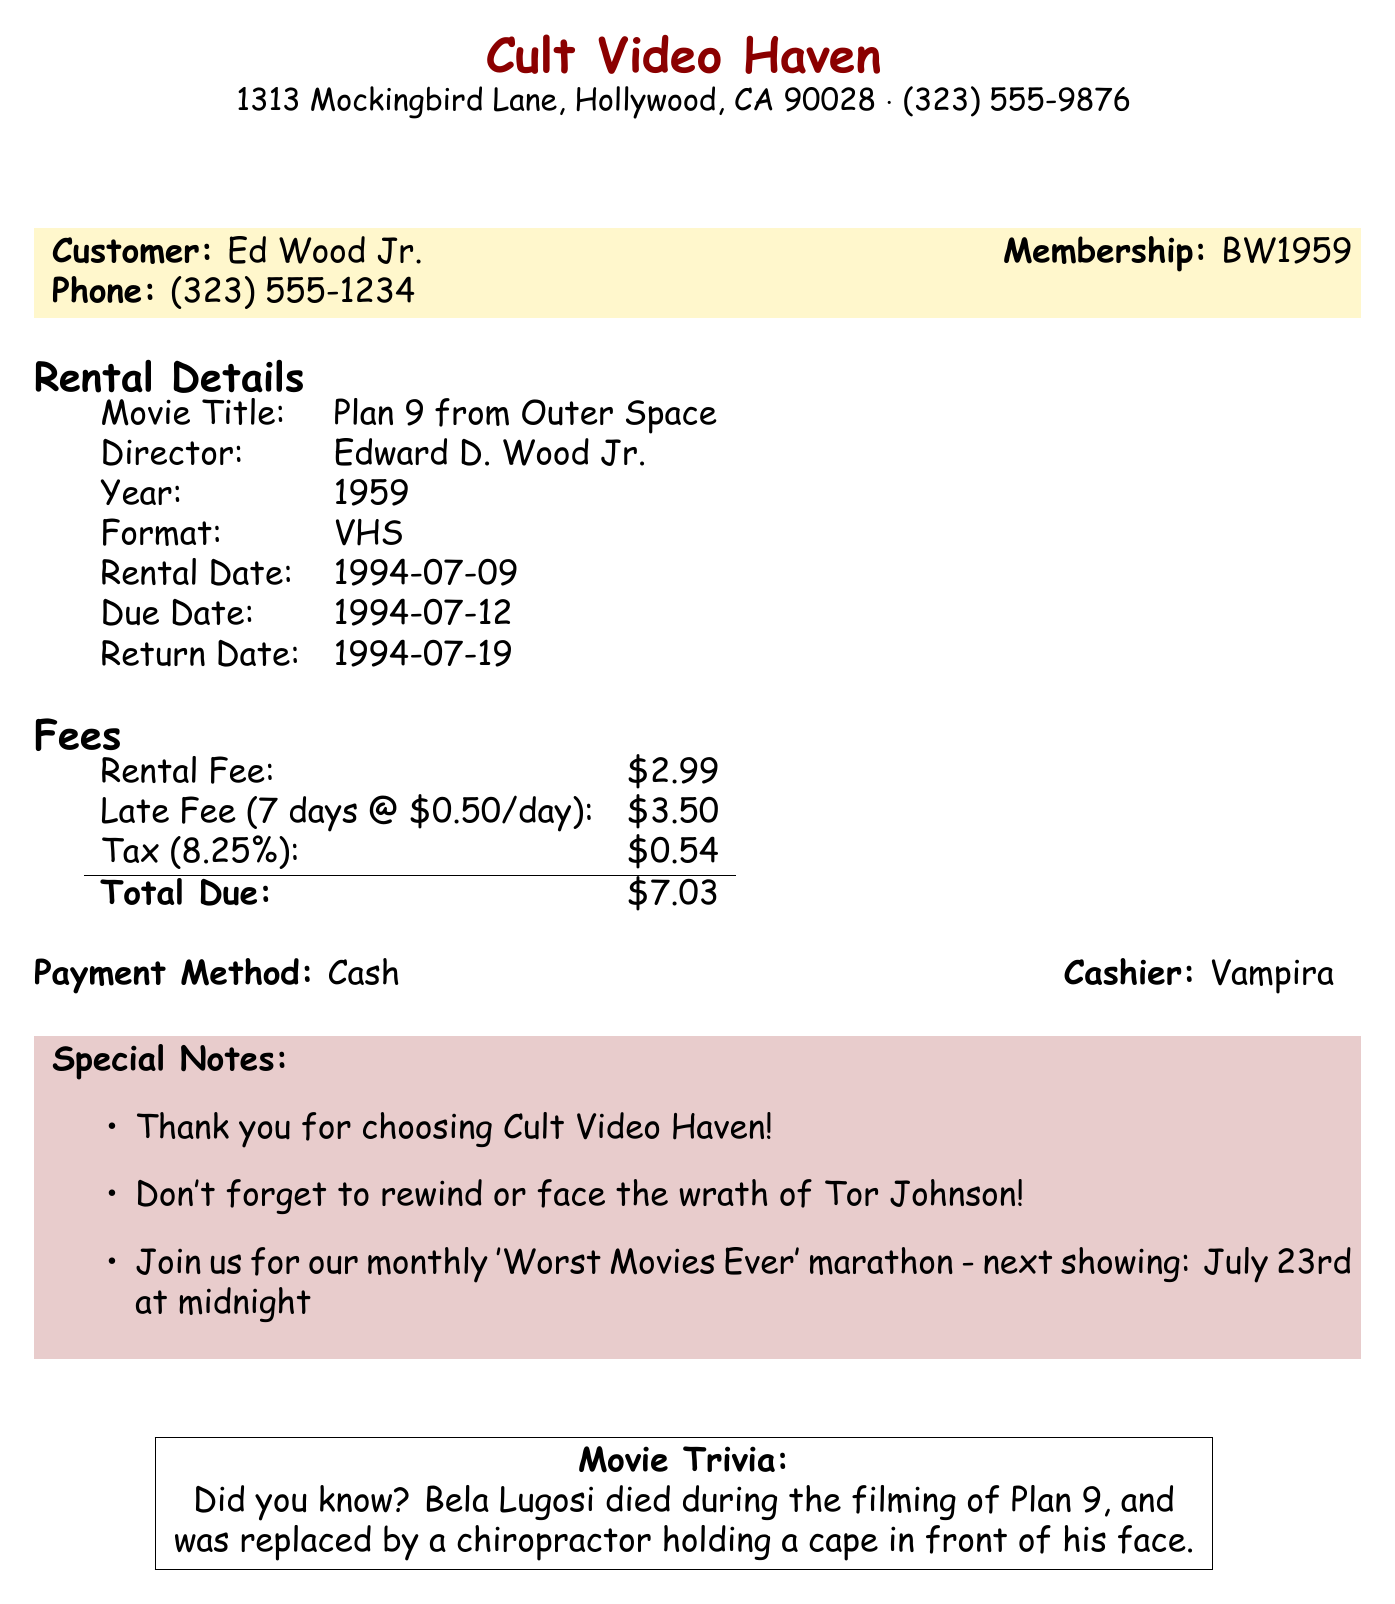what is the store name? The store name is specified at the top of the receipt.
Answer: Cult Video Haven who is the customer? The customer's name is mentioned in the document.
Answer: Ed Wood Jr what is the rental fee? The rental fee is listed in the fees section of the receipt.
Answer: $2.99 when was the rental due date? The due date for the rental is clearly stated in the rental details.
Answer: 1994-07-12 how much is the total late fee? The total late fee is calculated based on the daily late fee and the number of overdue days.
Answer: $3.50 what was the payment method? The payment method is specified in the fees section of the receipt.
Answer: Cash who served as the cashier? The name of the cashier is mentioned near the payment method.
Answer: Vampira how many days late was the return? This is calculated based on the due date and return date provided in the document.
Answer: 7 what trivia is mentioned about the movie? The trivia is included in a specific section at the bottom of the receipt.
Answer: Bela Lugosi died during the filming of Plan 9, and was replaced by a chiropractor holding a cape in front of his face 